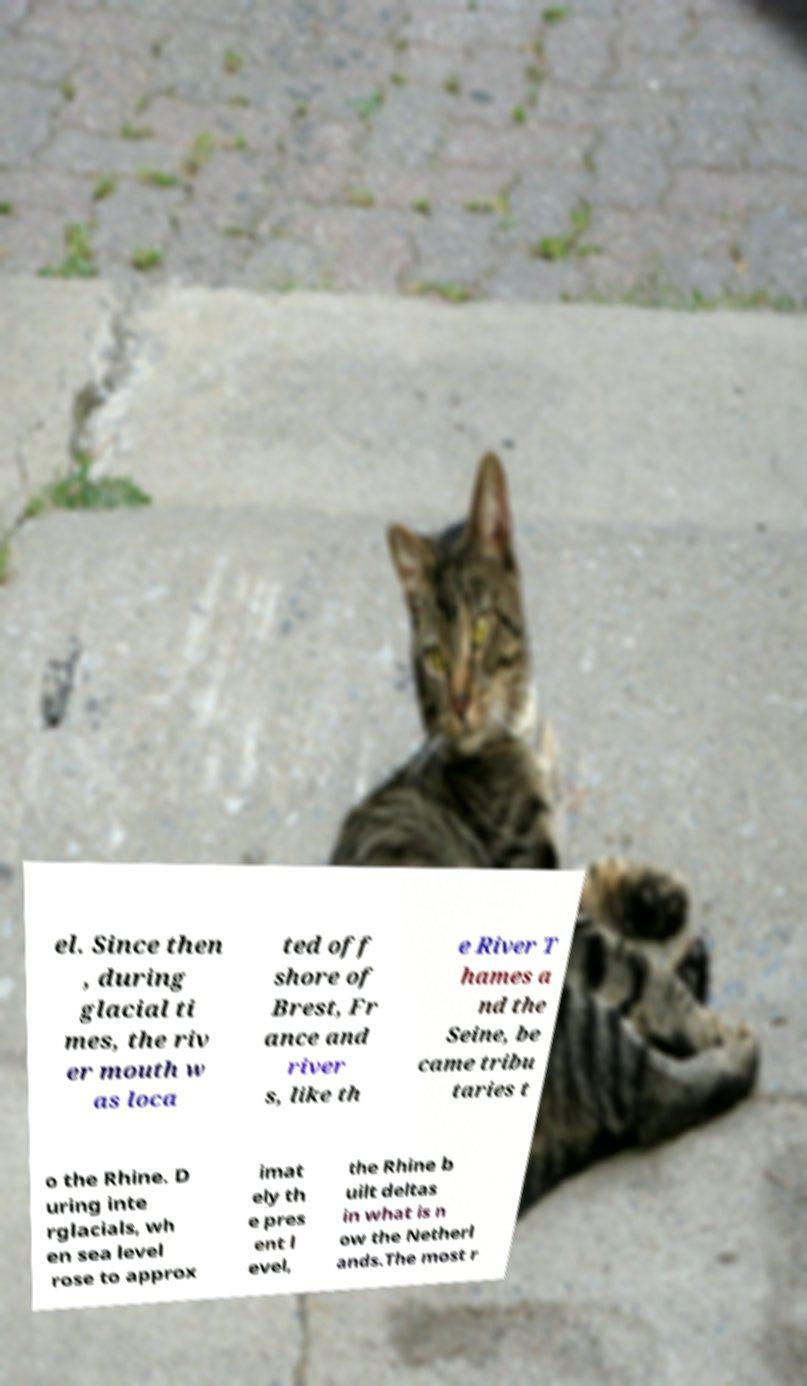Can you accurately transcribe the text from the provided image for me? el. Since then , during glacial ti mes, the riv er mouth w as loca ted off shore of Brest, Fr ance and river s, like th e River T hames a nd the Seine, be came tribu taries t o the Rhine. D uring inte rglacials, wh en sea level rose to approx imat ely th e pres ent l evel, the Rhine b uilt deltas in what is n ow the Netherl ands.The most r 